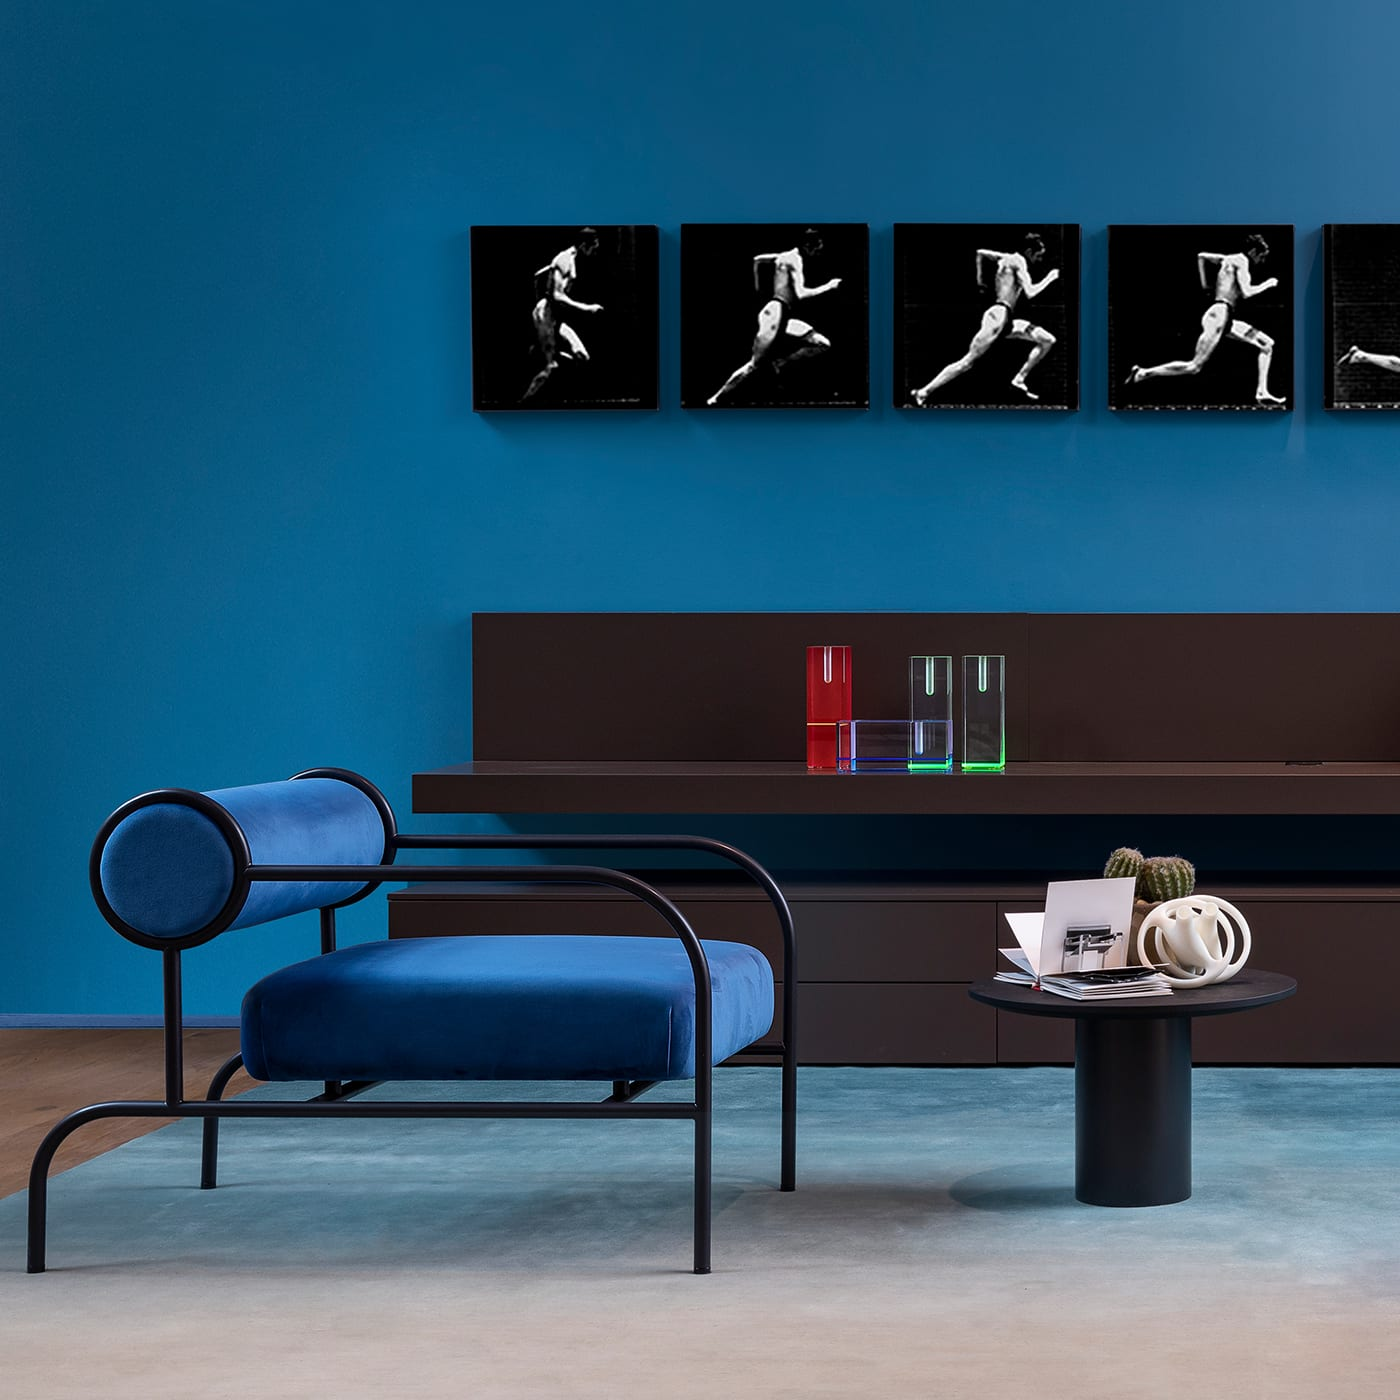How would you describe the overall atmosphere conveyed by the arrangement of the room? The overall atmosphere of the room conveys a blend of minimalism and modernity, supported by the deliberate placement of furniture and decor. The monochromatic color palette, mainly blue, along with select vibrant decor pieces, grants the space a chic yet inviting vibe. 